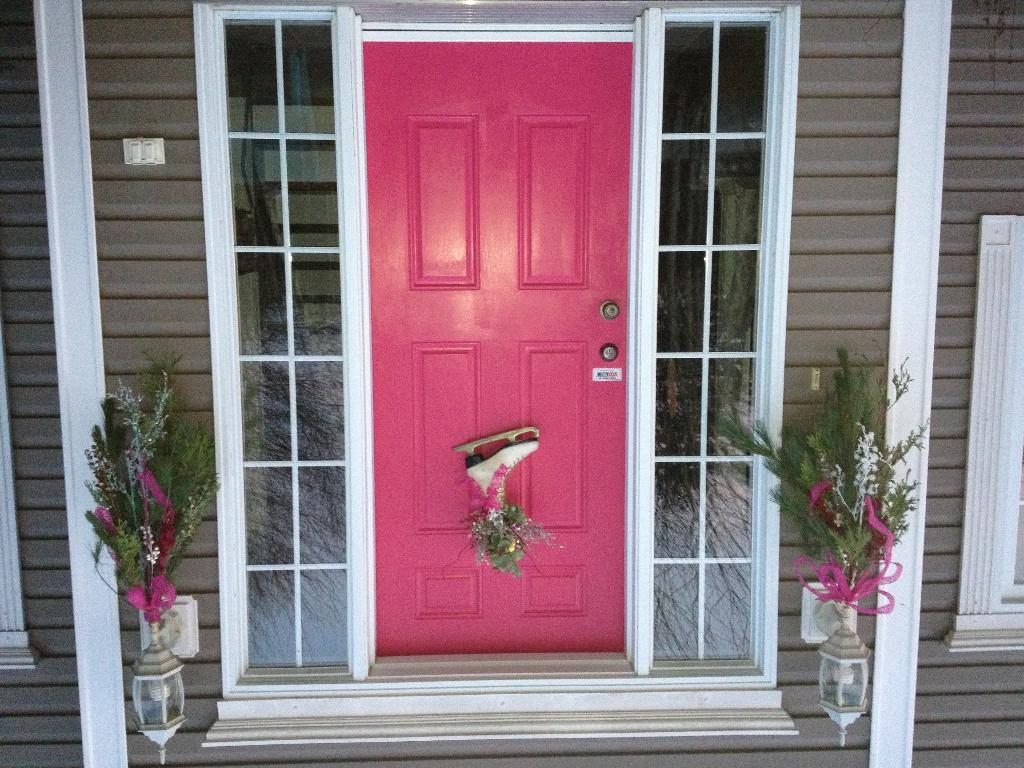What is one of the architectural features visible in the image? There is a door in the image. What type of decorative items can be seen in the image? There are flower vases in the image. What is used to provide illumination in the image? There are lights in the image. Where is the switch board located in the image? The switch board is on the wall in the image. What allows natural light to enter the space in the image? There are windows in the image. Can you see a man's throat in the image? There is no man or throat visible in the image. 